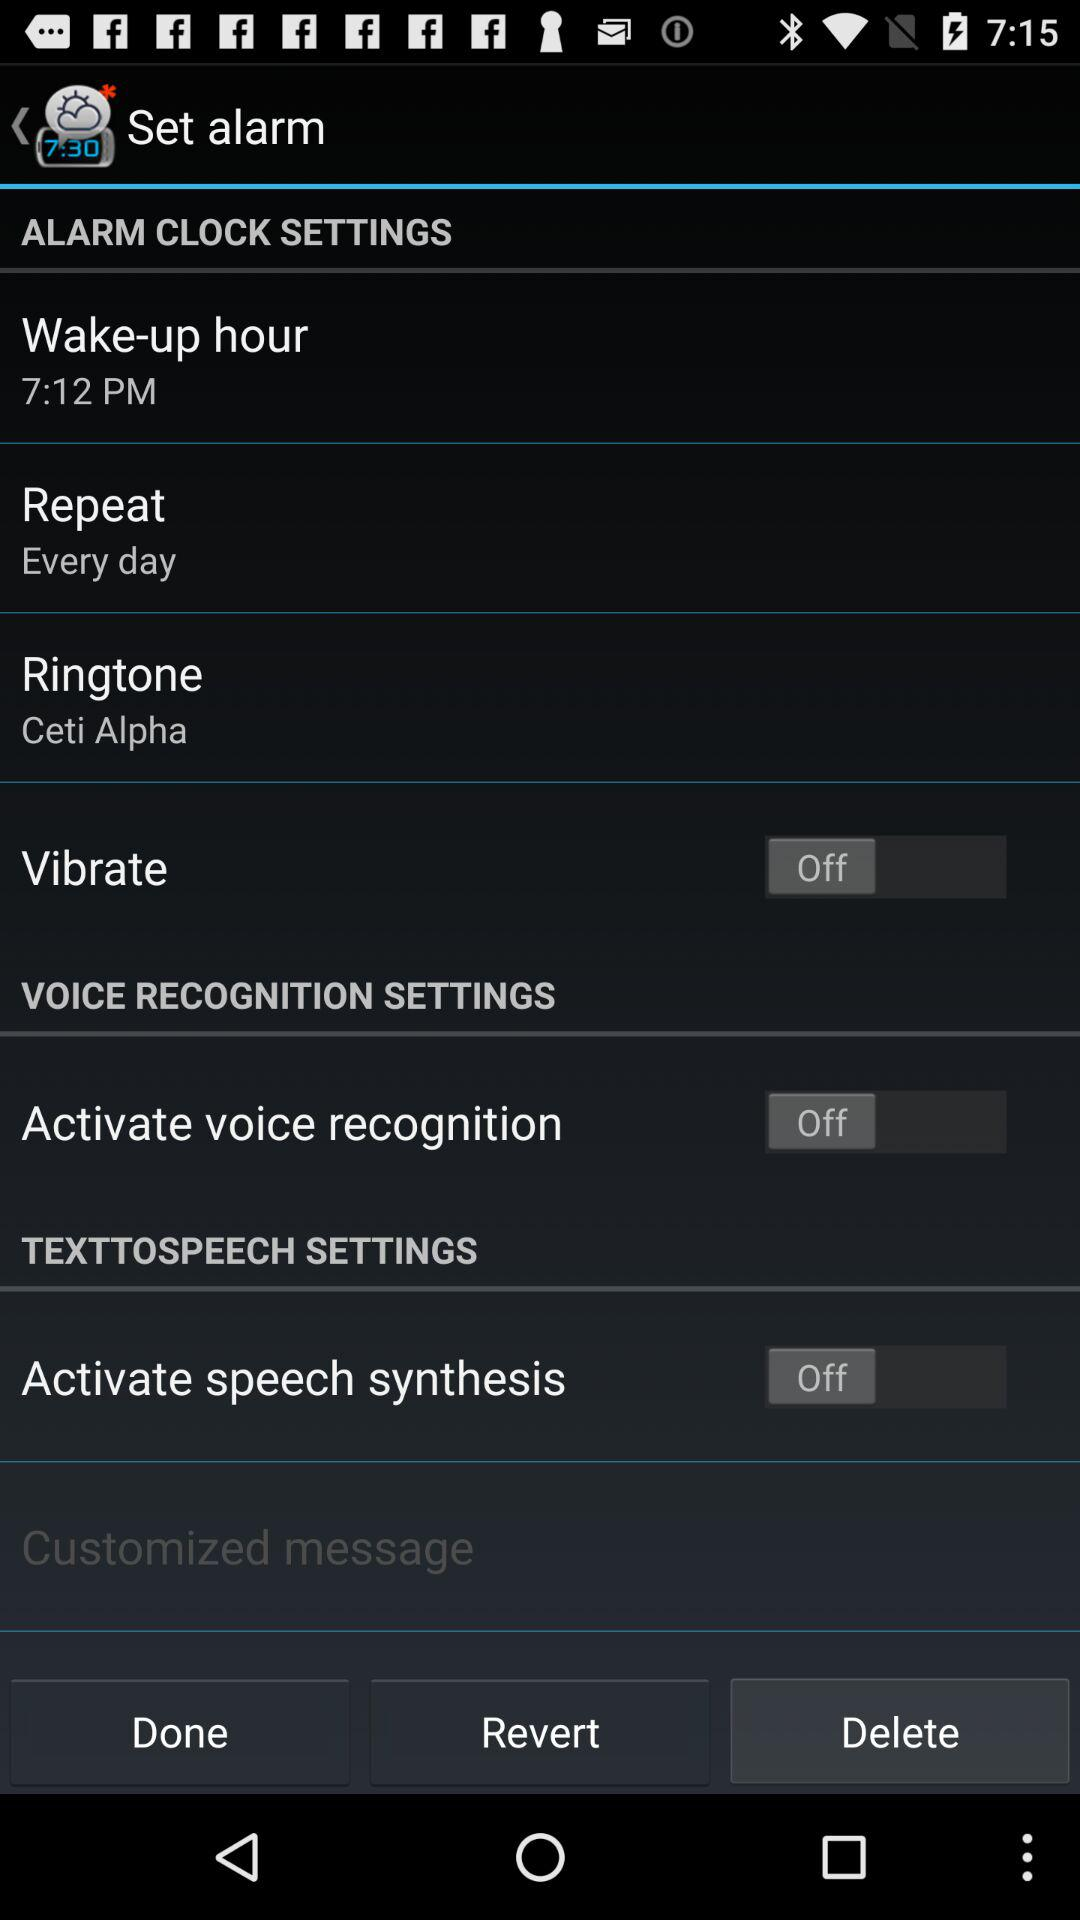What is the status of "Vibrate"? The status of "Vibrate" is "off". 